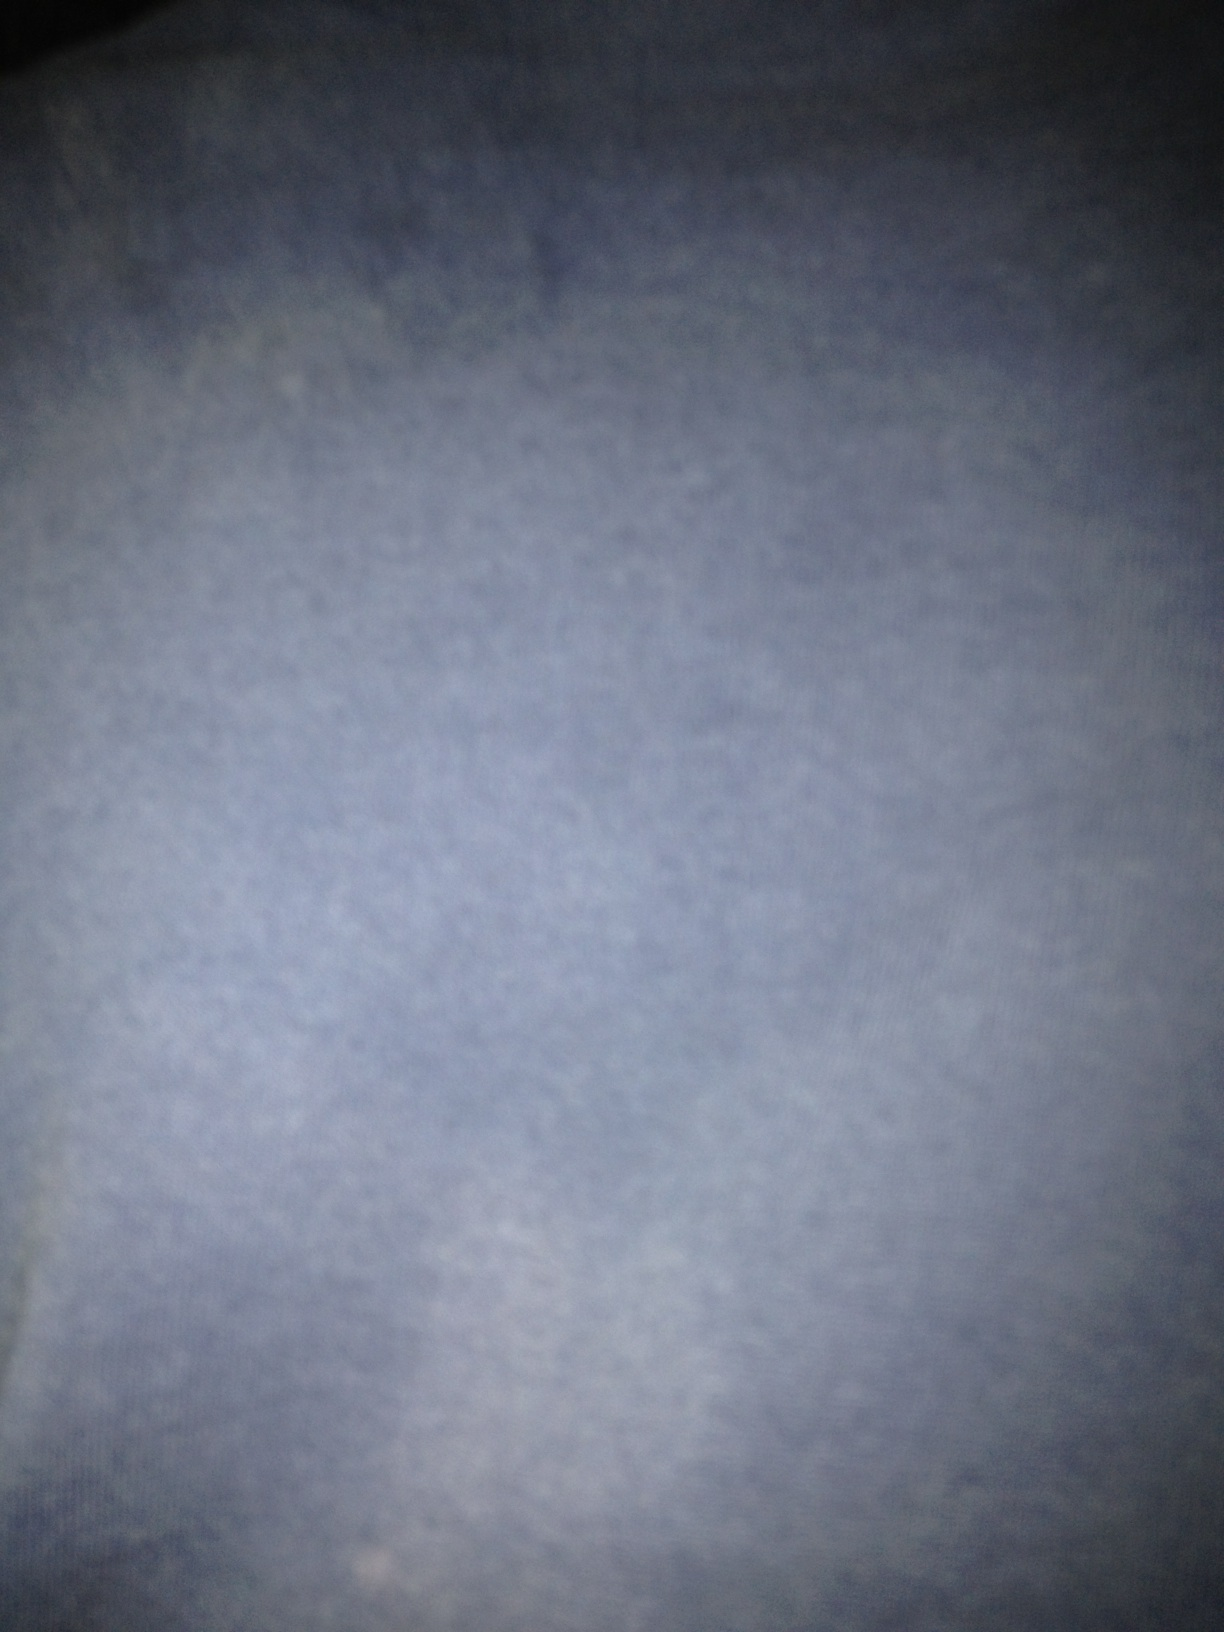Is there anything in the image that can hint at its location or setting? The lack of discernible features makes it impossible to deduce the location or setting of the image. It's highly blurred with no distinguishable elements that could give away its context. 